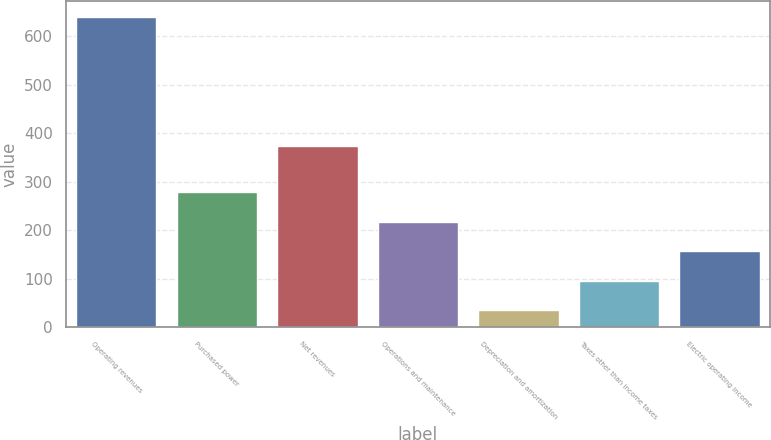Convert chart to OTSL. <chart><loc_0><loc_0><loc_500><loc_500><bar_chart><fcel>Operating revenues<fcel>Purchased power<fcel>Net revenues<fcel>Operations and maintenance<fcel>Depreciation and amortization<fcel>Taxes other than income taxes<fcel>Electric operating income<nl><fcel>641<fcel>278.6<fcel>374<fcel>218<fcel>35<fcel>95.6<fcel>156.2<nl></chart> 